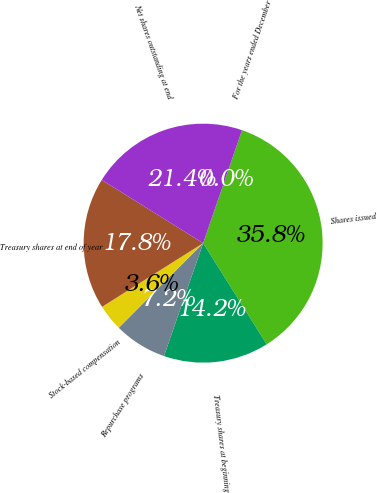Convert chart to OTSL. <chart><loc_0><loc_0><loc_500><loc_500><pie_chart><fcel>For the years ended December<fcel>Shares issued<fcel>Treasury shares at beginning<fcel>Repurchase programs<fcel>Stock-based compensation<fcel>Treasury shares at end of year<fcel>Net shares outstanding at end<nl><fcel>0.0%<fcel>35.8%<fcel>14.24%<fcel>7.16%<fcel>3.58%<fcel>17.82%<fcel>21.4%<nl></chart> 